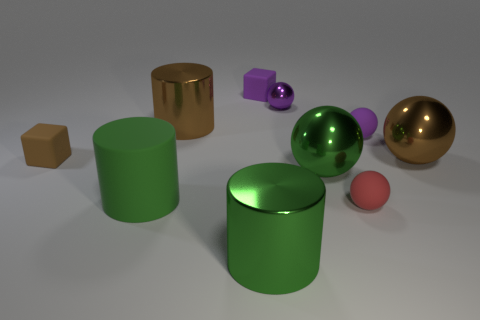What is the size of the purple cube that is the same material as the tiny brown cube?
Offer a terse response. Small. How many purple objects are large matte objects or large shiny balls?
Provide a succinct answer. 0. Is there any other thing that has the same material as the large brown cylinder?
Provide a succinct answer. Yes. Do the shiny object that is in front of the big rubber object and the small object behind the small purple shiny sphere have the same shape?
Make the answer very short. No. What number of big brown shiny blocks are there?
Offer a terse response. 0. What shape is the tiny brown object that is made of the same material as the tiny red thing?
Make the answer very short. Cube. Is there any other thing of the same color as the matte cylinder?
Make the answer very short. Yes. Do the tiny shiny object and the small thing that is to the left of the purple cube have the same color?
Provide a succinct answer. No. Are there fewer large shiny things that are behind the green rubber object than purple objects?
Give a very brief answer. No. What is the ball right of the small purple rubber ball made of?
Your answer should be very brief. Metal. 